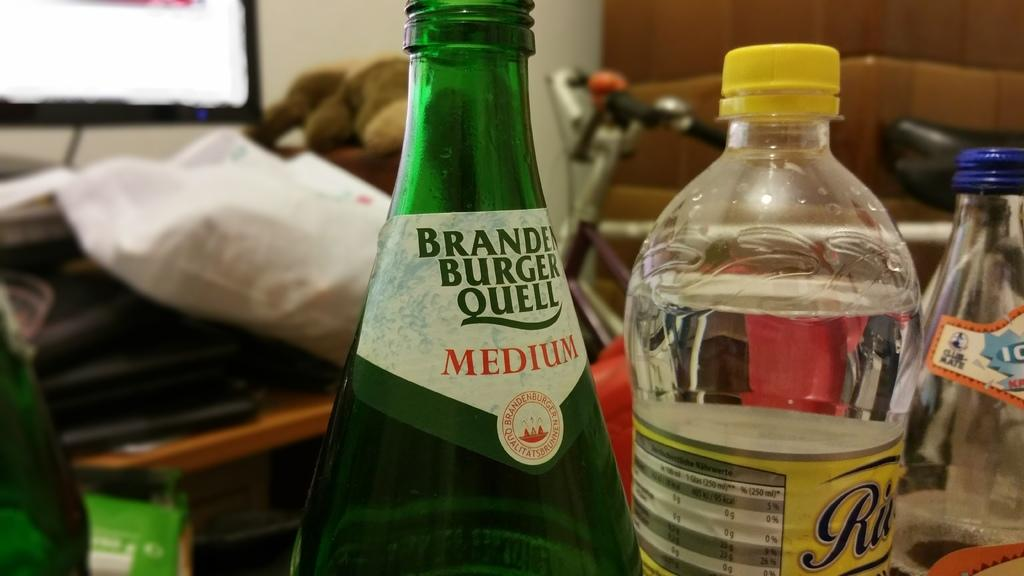<image>
Share a concise interpretation of the image provided. A green beverage bottle has the word "medium" on it. 